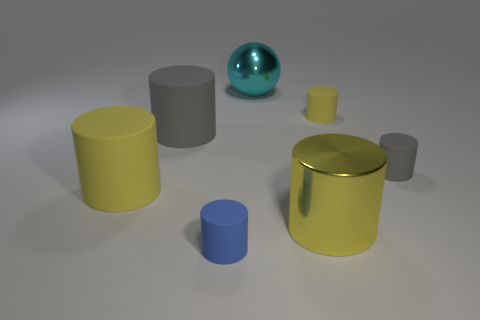How many tiny objects are either gray objects or spheres?
Your answer should be compact. 1. What number of big yellow cylinders are behind the tiny gray matte cylinder?
Your answer should be very brief. 0. Are there more yellow rubber cylinders that are in front of the large gray cylinder than small red shiny balls?
Your answer should be compact. Yes. There is a yellow object that is made of the same material as the cyan object; what shape is it?
Make the answer very short. Cylinder. There is a tiny thing that is in front of the gray thing that is right of the cyan ball; what color is it?
Your response must be concise. Blue. Is the large yellow shiny thing the same shape as the cyan metal object?
Keep it short and to the point. No. There is a blue thing that is the same shape as the small gray rubber object; what is it made of?
Your response must be concise. Rubber. There is a big cylinder that is behind the gray matte cylinder that is on the right side of the tiny yellow cylinder; are there any yellow rubber objects that are behind it?
Offer a very short reply. Yes. There is a large yellow metallic thing; does it have the same shape as the yellow rubber thing to the left of the big metal cylinder?
Offer a very short reply. Yes. Are there any other things that are the same color as the big metal cylinder?
Provide a succinct answer. Yes. 